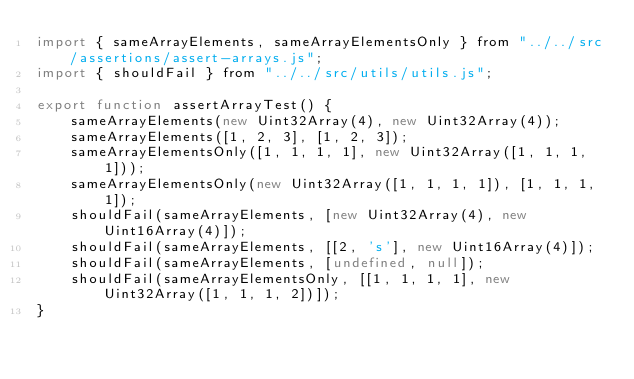<code> <loc_0><loc_0><loc_500><loc_500><_JavaScript_>import { sameArrayElements, sameArrayElementsOnly } from "../../src/assertions/assert-arrays.js";
import { shouldFail } from "../../src/utils/utils.js";

export function assertArrayTest() {
    sameArrayElements(new Uint32Array(4), new Uint32Array(4));
    sameArrayElements([1, 2, 3], [1, 2, 3]);
    sameArrayElementsOnly([1, 1, 1, 1], new Uint32Array([1, 1, 1, 1]));
    sameArrayElementsOnly(new Uint32Array([1, 1, 1, 1]), [1, 1, 1, 1]);
    shouldFail(sameArrayElements, [new Uint32Array(4), new Uint16Array(4)]);
    shouldFail(sameArrayElements, [[2, 's'], new Uint16Array(4)]);
    shouldFail(sameArrayElements, [undefined, null]);
    shouldFail(sameArrayElementsOnly, [[1, 1, 1, 1], new Uint32Array([1, 1, 1, 2])]);
}
</code> 